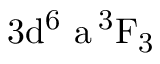Convert formula to latex. <formula><loc_0><loc_0><loc_500><loc_500>3 d ^ { 6 } \ a \, ^ { 3 } F _ { 3 }</formula> 